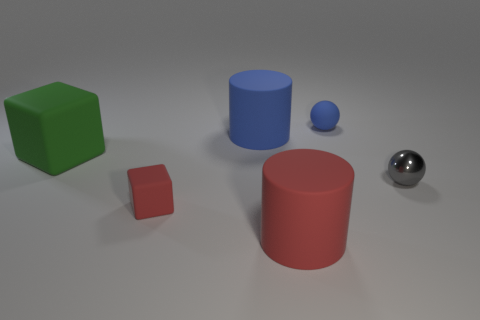Add 3 large blue matte objects. How many objects exist? 9 Subtract all balls. How many objects are left? 4 Subtract all large red metal spheres. Subtract all green objects. How many objects are left? 5 Add 3 blue objects. How many blue objects are left? 5 Add 3 tiny blue spheres. How many tiny blue spheres exist? 4 Subtract 0 yellow cubes. How many objects are left? 6 